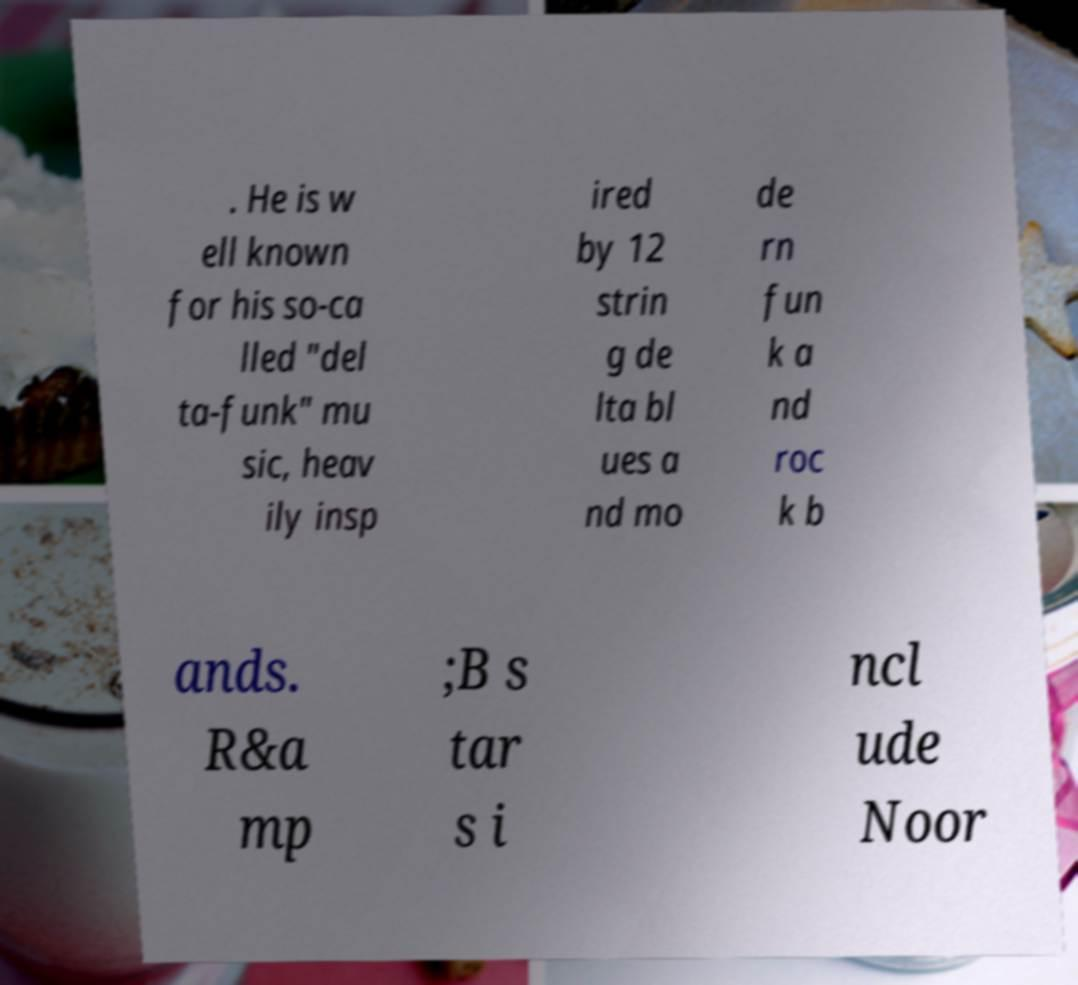What messages or text are displayed in this image? I need them in a readable, typed format. . He is w ell known for his so-ca lled "del ta-funk" mu sic, heav ily insp ired by 12 strin g de lta bl ues a nd mo de rn fun k a nd roc k b ands. R&a mp ;B s tar s i ncl ude Noor 